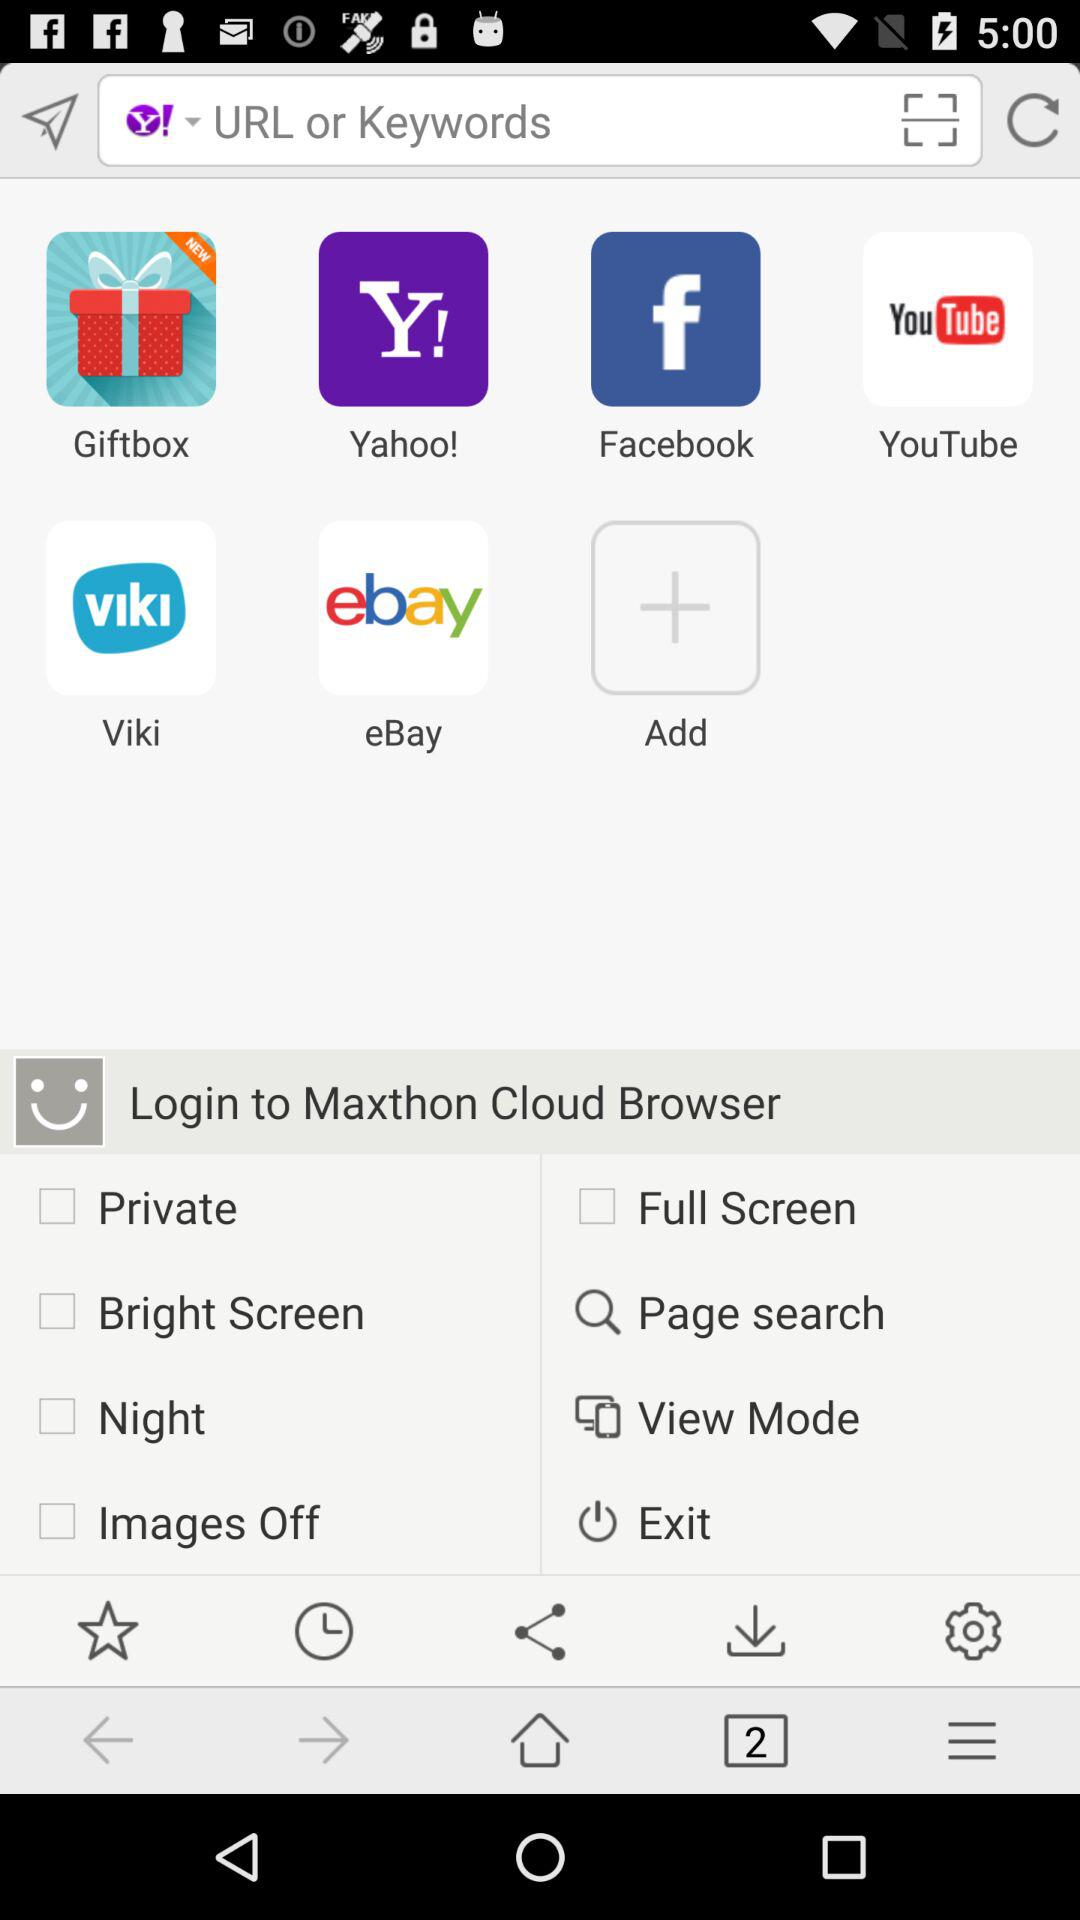Which options are checked?
When the provided information is insufficient, respond with <no answer>. <no answer> 